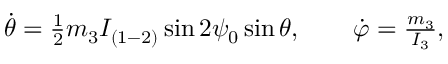Convert formula to latex. <formula><loc_0><loc_0><loc_500><loc_500>\begin{array} { r } { \dot { \theta } = \frac { 1 } { 2 } m _ { 3 } I _ { ( 1 - 2 ) } \sin 2 \psi _ { 0 } \sin \theta , \quad \dot { \varphi } = \frac { m _ { 3 } } { I _ { 3 } } , } \end{array}</formula> 